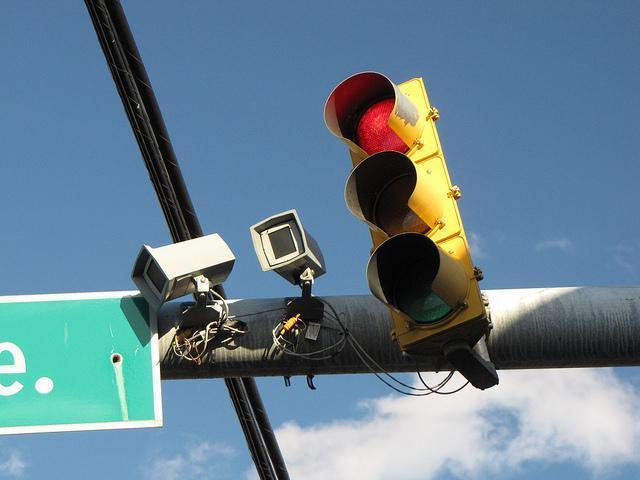How many red lights?
Give a very brief answer. 1. 